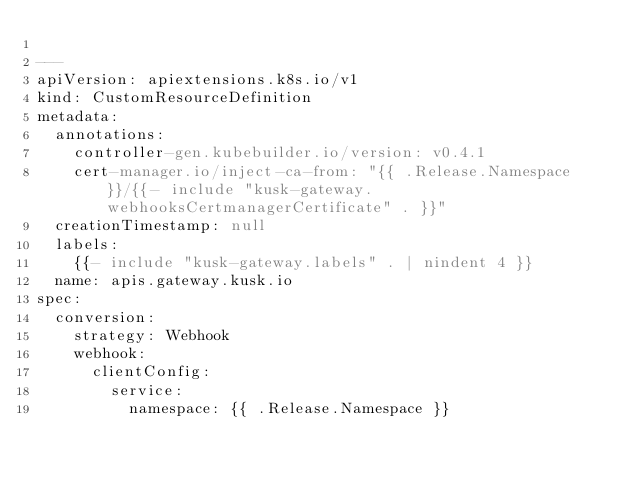Convert code to text. <code><loc_0><loc_0><loc_500><loc_500><_YAML_>
---
apiVersion: apiextensions.k8s.io/v1
kind: CustomResourceDefinition
metadata:
  annotations:
    controller-gen.kubebuilder.io/version: v0.4.1
    cert-manager.io/inject-ca-from: "{{ .Release.Namespace }}/{{- include "kusk-gateway.webhooksCertmanagerCertificate" . }}"
  creationTimestamp: null
  labels:
    {{- include "kusk-gateway.labels" . | nindent 4 }}
  name: apis.gateway.kusk.io
spec:
  conversion:
    strategy: Webhook
    webhook:
      clientConfig:
        service:
          namespace: {{ .Release.Namespace }}</code> 